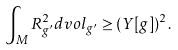Convert formula to latex. <formula><loc_0><loc_0><loc_500><loc_500>\int _ { M } R _ { g ^ { \prime } } ^ { 2 } d v o l _ { g ^ { \prime } } \geq ( Y [ g ] ) ^ { 2 } .</formula> 